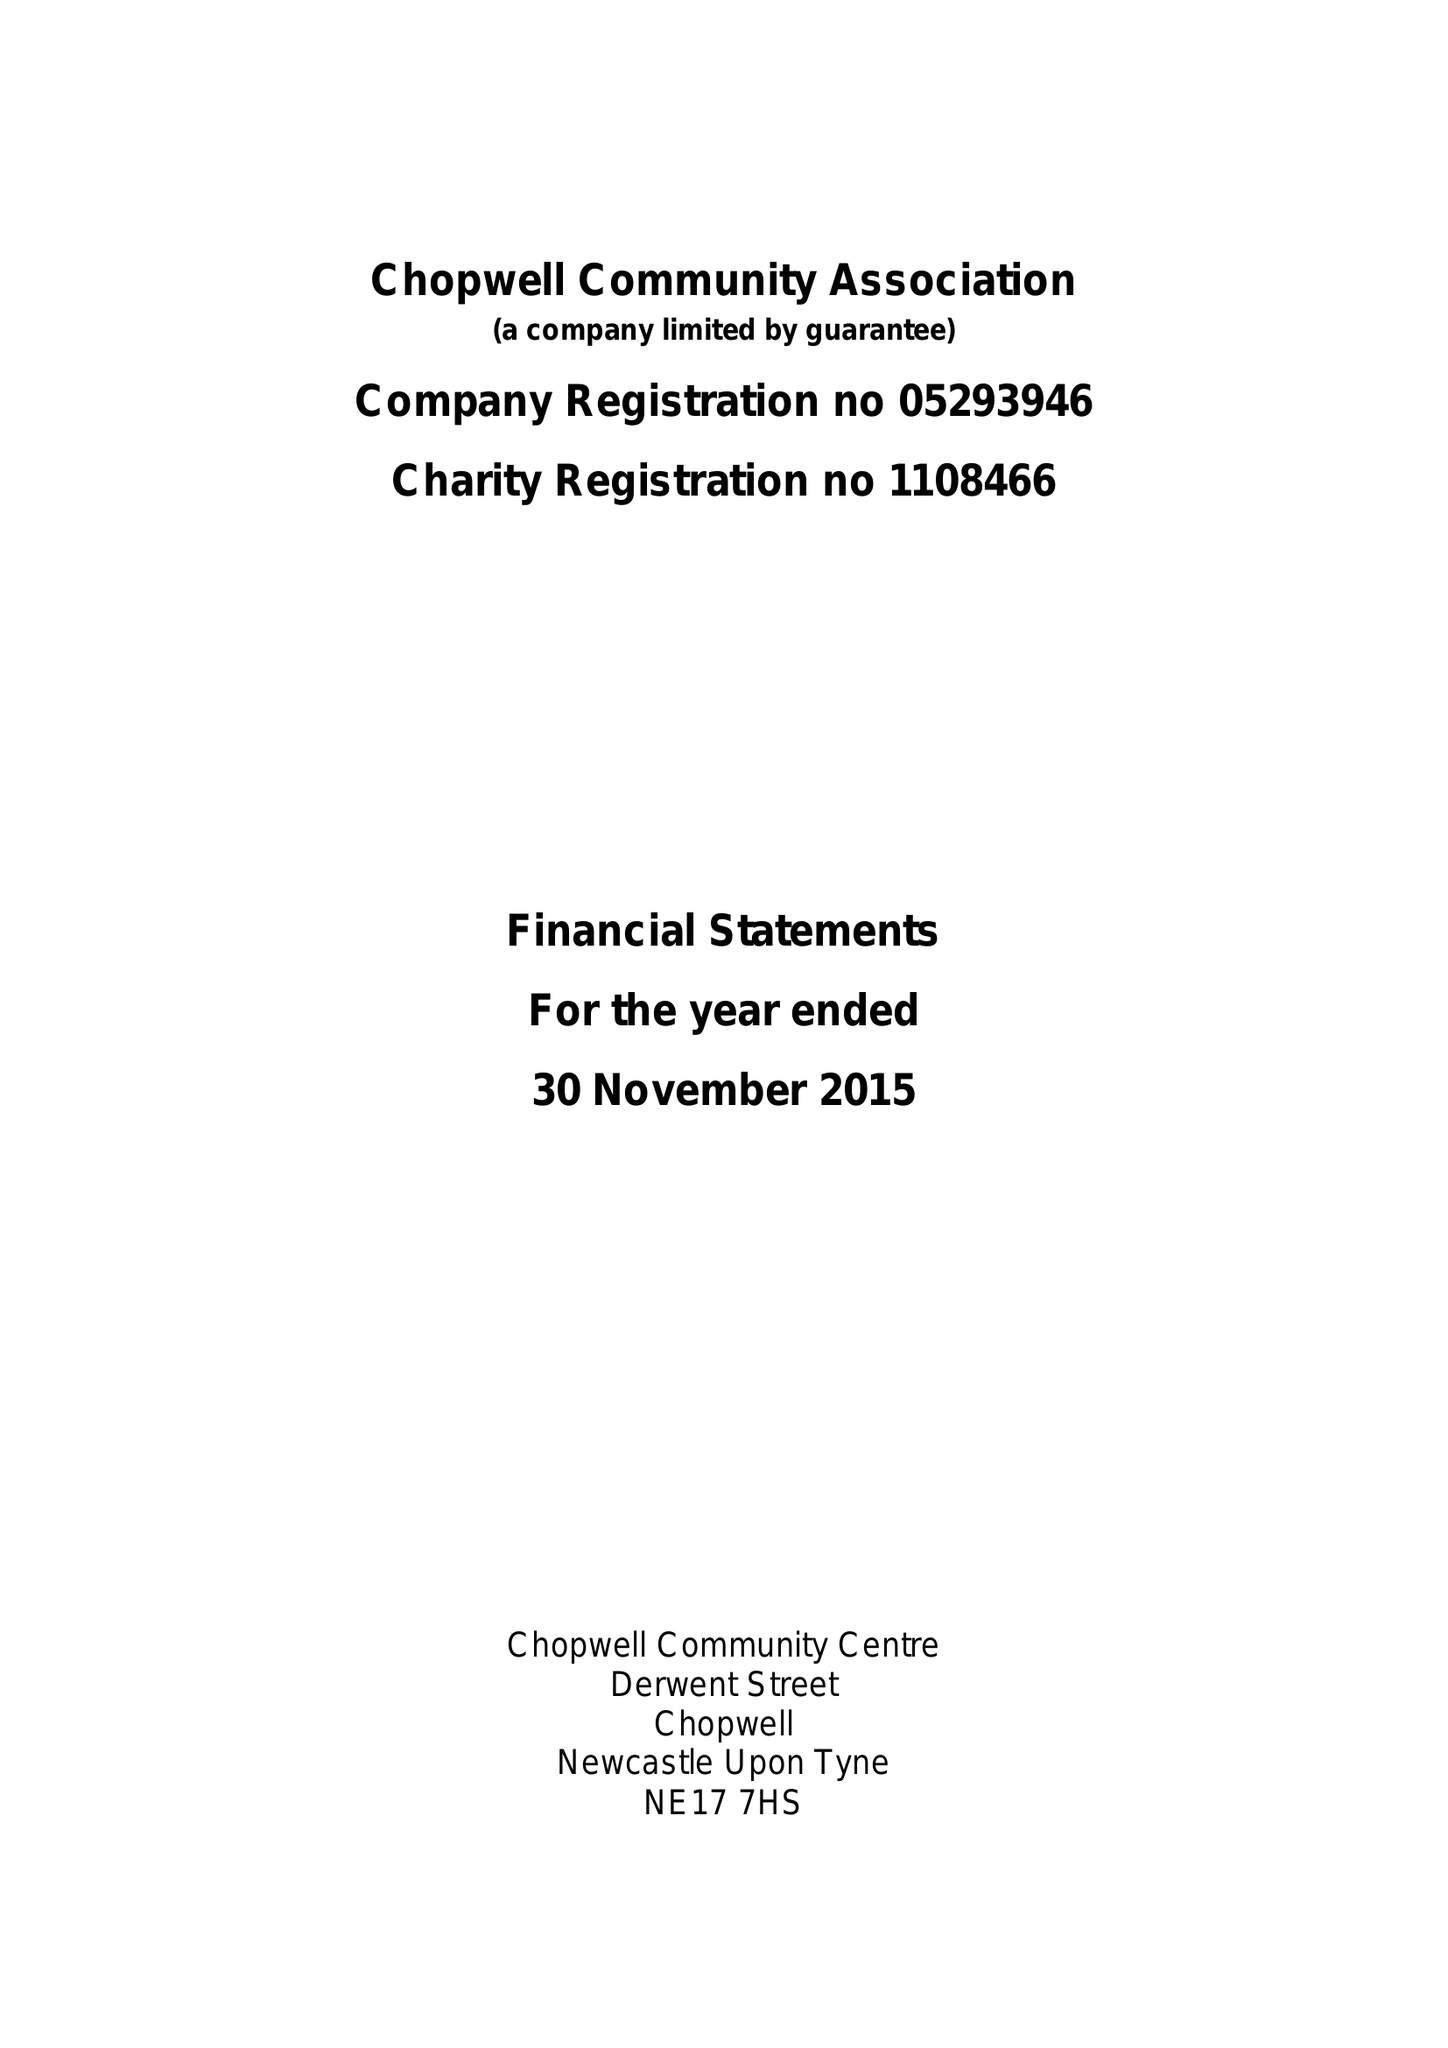What is the value for the address__street_line?
Answer the question using a single word or phrase. 34 MILL ROAD 